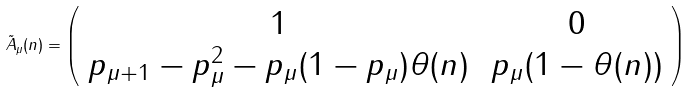Convert formula to latex. <formula><loc_0><loc_0><loc_500><loc_500>\tilde { A } _ { \mu } ( n ) = \left ( \begin{array} { c c } 1 & \, 0 \\ p _ { \mu + 1 } - p _ { \mu } ^ { 2 } - p _ { \mu } ( 1 - p _ { \mu } ) \theta ( n ) & \, p _ { \mu } ( 1 - \theta ( n ) ) \end{array} \right )</formula> 